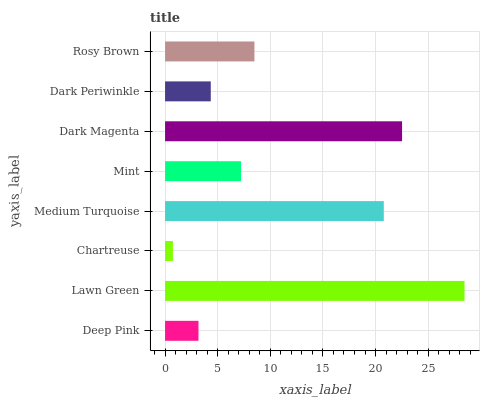Is Chartreuse the minimum?
Answer yes or no. Yes. Is Lawn Green the maximum?
Answer yes or no. Yes. Is Lawn Green the minimum?
Answer yes or no. No. Is Chartreuse the maximum?
Answer yes or no. No. Is Lawn Green greater than Chartreuse?
Answer yes or no. Yes. Is Chartreuse less than Lawn Green?
Answer yes or no. Yes. Is Chartreuse greater than Lawn Green?
Answer yes or no. No. Is Lawn Green less than Chartreuse?
Answer yes or no. No. Is Rosy Brown the high median?
Answer yes or no. Yes. Is Mint the low median?
Answer yes or no. Yes. Is Dark Magenta the high median?
Answer yes or no. No. Is Deep Pink the low median?
Answer yes or no. No. 